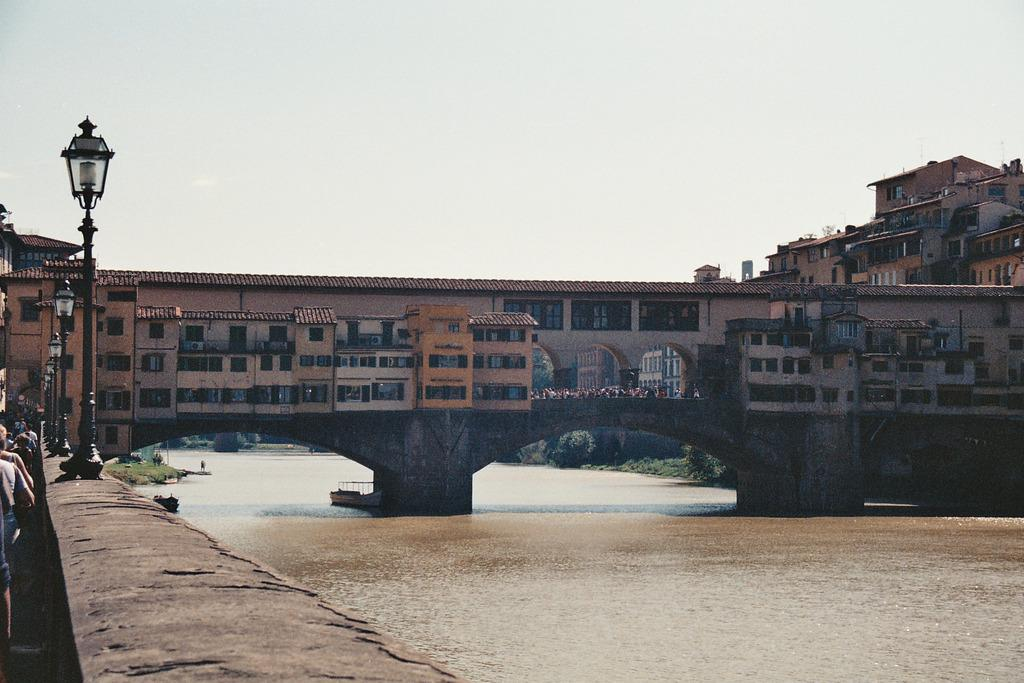What is visible in the image? Water, a wall, persons standing on the ground, poles, buildings, trees in the background, and the sky in the background are visible in the image. Can you describe the setting of the image? The image shows a scene with water, a wall, and buildings, with persons standing on the ground. There are also poles, trees in the background, and the sky visible in the background. What type of structures can be seen in the image? Buildings and poles are the structures visible in the image. What is the natural environment visible in the image? Trees and the sky are the natural elements visible in the image. What type of sweater is hanging on the shelf in the image? There is no sweater or shelf present in the image. 